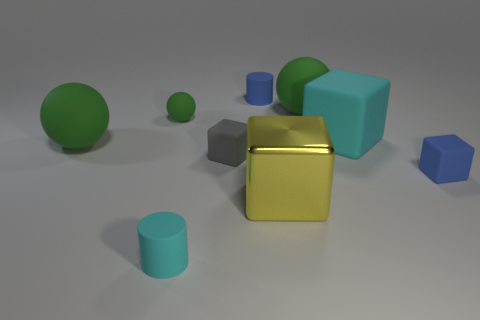There is a tiny rubber sphere; is its color the same as the large object on the left side of the tiny cyan matte cylinder? The tiny rubber sphere appears to be green, a hue shared with the sizable cube-shaped object to the left of the small cyan cylinder. Despite the difference in size and shade variations due to lighting and texture, both objects possess the overarching characteristic of green coloration. 